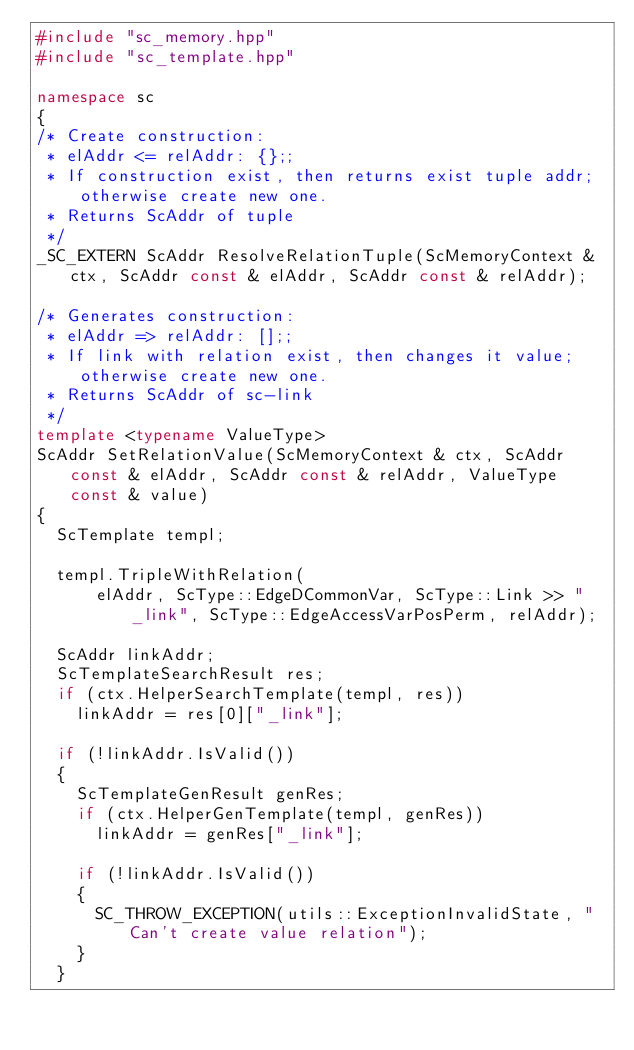<code> <loc_0><loc_0><loc_500><loc_500><_C++_>#include "sc_memory.hpp"
#include "sc_template.hpp"

namespace sc
{
/* Create construction:
 * elAddr <= relAddr: {};;
 * If construction exist, then returns exist tuple addr; otherwise create new one.
 * Returns ScAddr of tuple
 */
_SC_EXTERN ScAddr ResolveRelationTuple(ScMemoryContext & ctx, ScAddr const & elAddr, ScAddr const & relAddr);

/* Generates construction:
 * elAddr => relAddr: [];;
 * If link with relation exist, then changes it value; otherwise create new one.
 * Returns ScAddr of sc-link
 */
template <typename ValueType>
ScAddr SetRelationValue(ScMemoryContext & ctx, ScAddr const & elAddr, ScAddr const & relAddr, ValueType const & value)
{
  ScTemplate templ;

  templ.TripleWithRelation(
      elAddr, ScType::EdgeDCommonVar, ScType::Link >> "_link", ScType::EdgeAccessVarPosPerm, relAddr);

  ScAddr linkAddr;
  ScTemplateSearchResult res;
  if (ctx.HelperSearchTemplate(templ, res))
    linkAddr = res[0]["_link"];

  if (!linkAddr.IsValid())
  {
    ScTemplateGenResult genRes;
    if (ctx.HelperGenTemplate(templ, genRes))
      linkAddr = genRes["_link"];

    if (!linkAddr.IsValid())
    {
      SC_THROW_EXCEPTION(utils::ExceptionInvalidState, "Can't create value relation");
    }
  }
</code> 